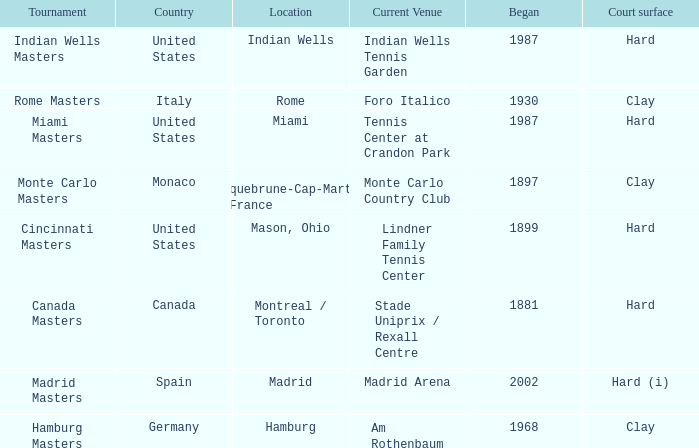Which tournaments current venue is the Madrid Arena? Madrid Masters. 